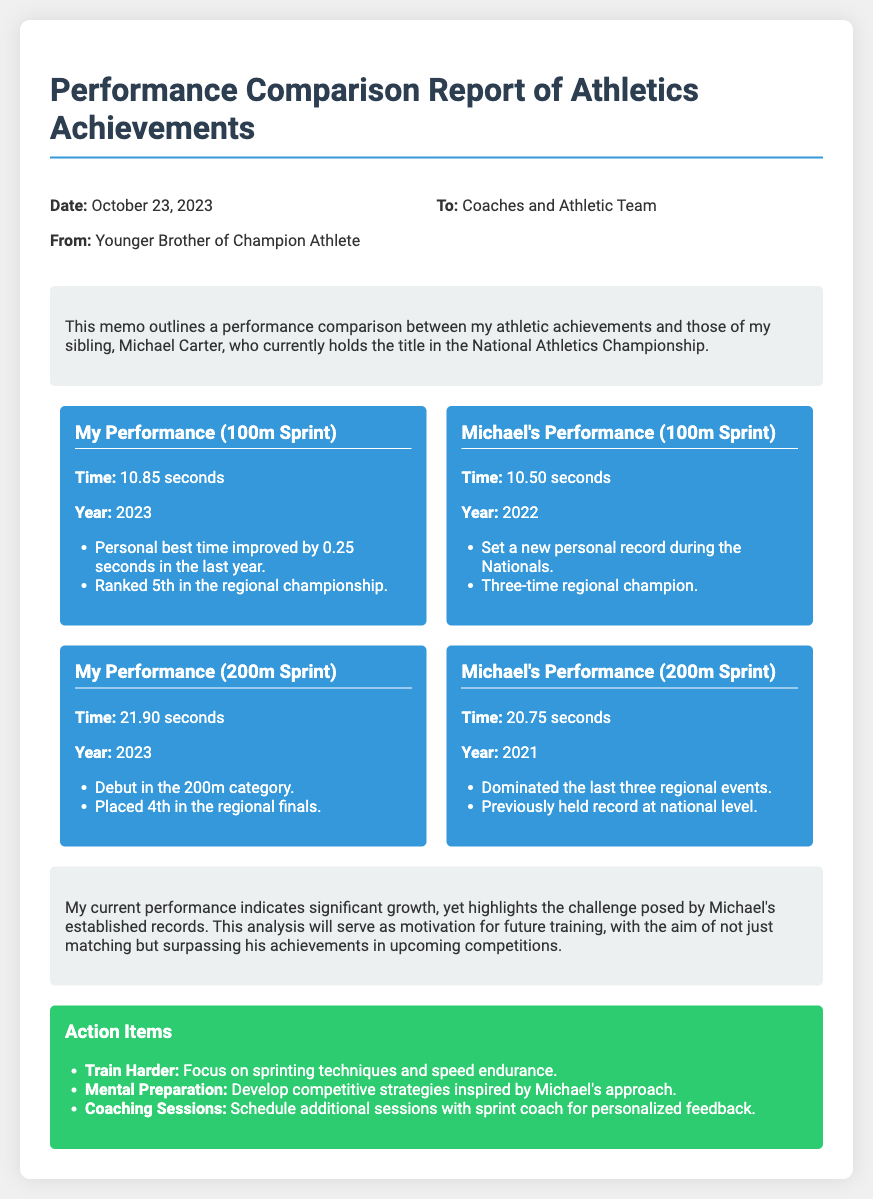What is the date of the memo? The date is explicitly stated in the document header as October 23, 2023.
Answer: October 23, 2023 Who is the sender of the memo? The sender is specified at the top of the memo as the Younger Brother of Champion Athlete.
Answer: Younger Brother of Champion Athlete What is my best time in the 100m Sprint? The document lists my best time in the 100m Sprint as 10.85 seconds.
Answer: 10.85 seconds What title does Michael Carter hold? The memo indicates that Michael Carter is the reigning champion in the National Athletics Championship.
Answer: National Athletics Championship How many regional championships has Michael won? The memo states that Michael has been a three-time regional champion.
Answer: Three-time What was my placement in the 200m Sprint at the regional finals? The document mentions that I placed 4th in the regional finals for the 200m Sprint.
Answer: 4th What specific action item focuses on mental preparedness? The action item related to mental preparedness is to develop competitive strategies inspired by Michael's approach.
Answer: Develop competitive strategies How did I improve my 100m Sprint time? The memo notes that I improved my personal best time by 0.25 seconds in the last year.
Answer: Improved by 0.25 seconds What year did Michael set his personal record in the 100m Sprint? According to the document, Michael set his personal record in the year 2022.
Answer: 2022 